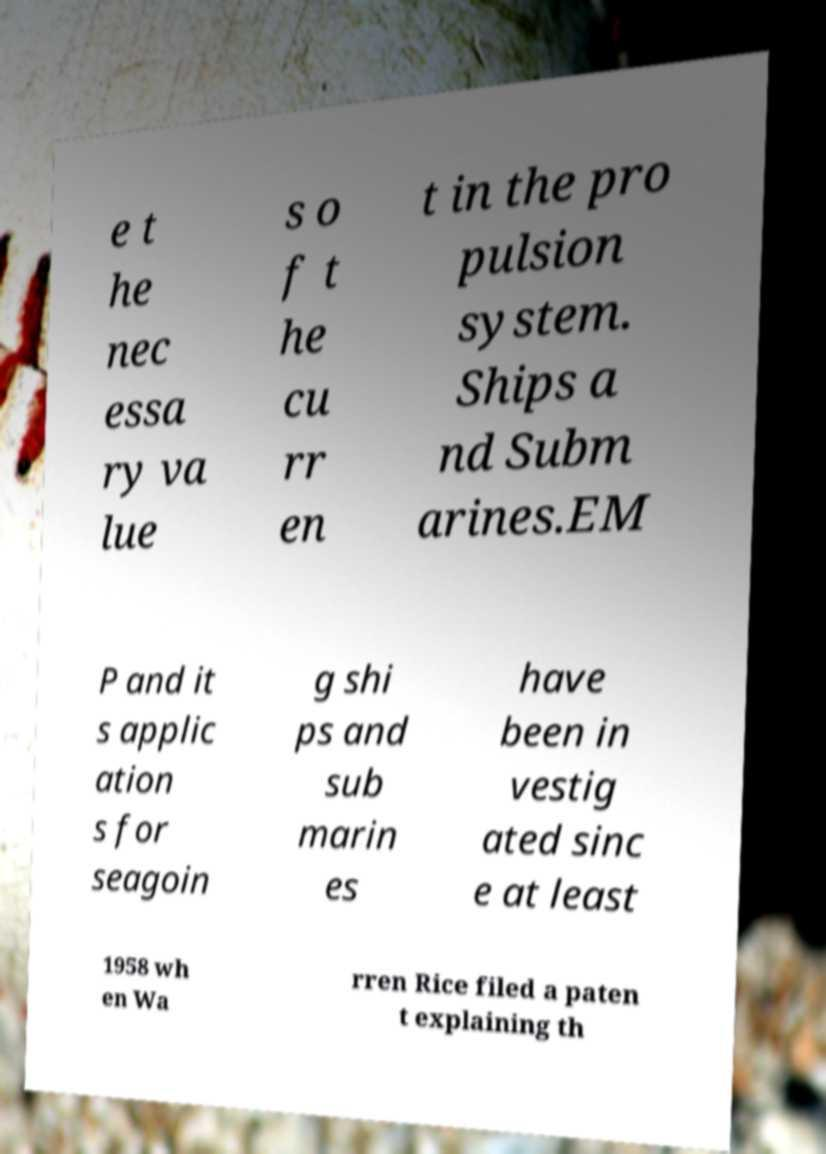What messages or text are displayed in this image? I need them in a readable, typed format. e t he nec essa ry va lue s o f t he cu rr en t in the pro pulsion system. Ships a nd Subm arines.EM P and it s applic ation s for seagoin g shi ps and sub marin es have been in vestig ated sinc e at least 1958 wh en Wa rren Rice filed a paten t explaining th 